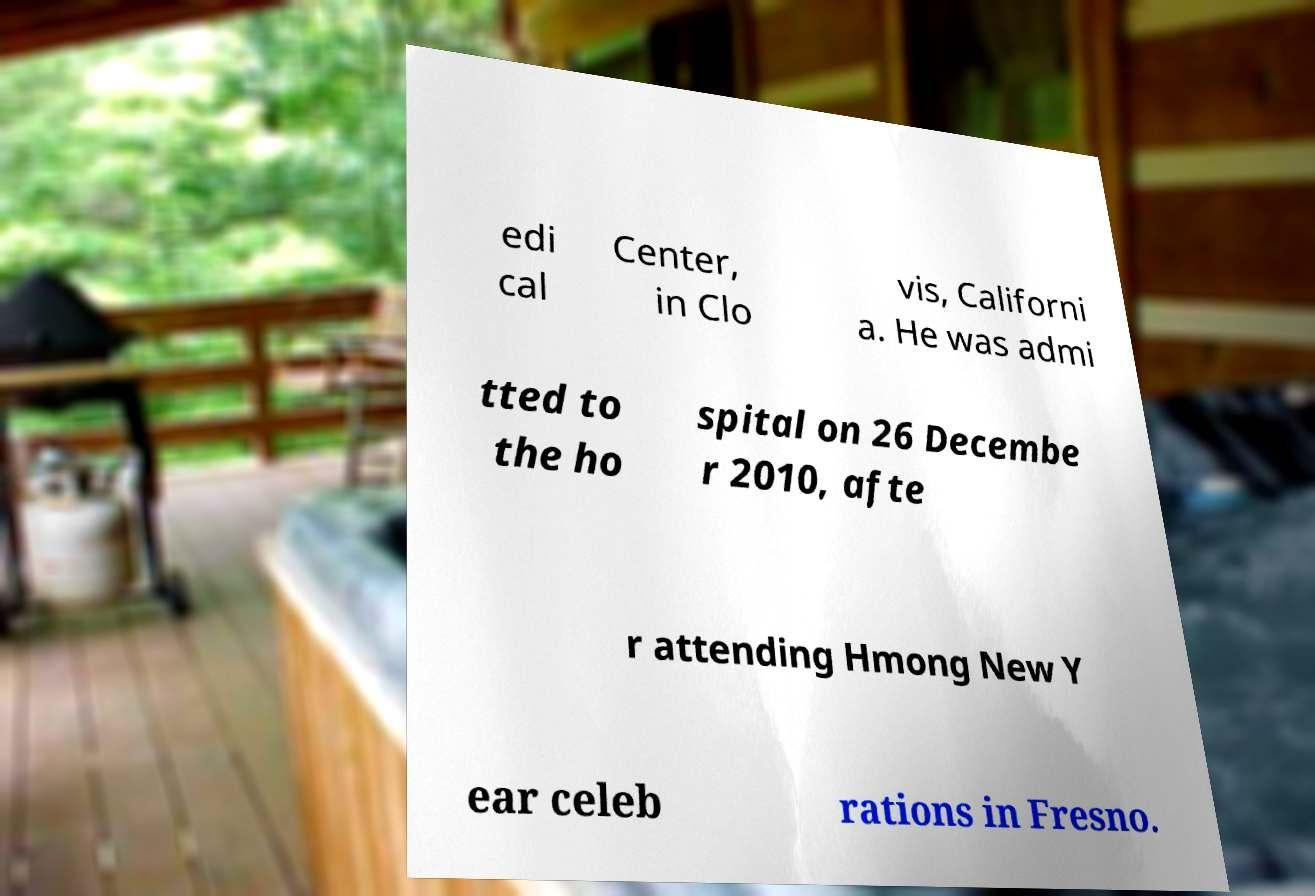I need the written content from this picture converted into text. Can you do that? edi cal Center, in Clo vis, Californi a. He was admi tted to the ho spital on 26 Decembe r 2010, afte r attending Hmong New Y ear celeb rations in Fresno. 